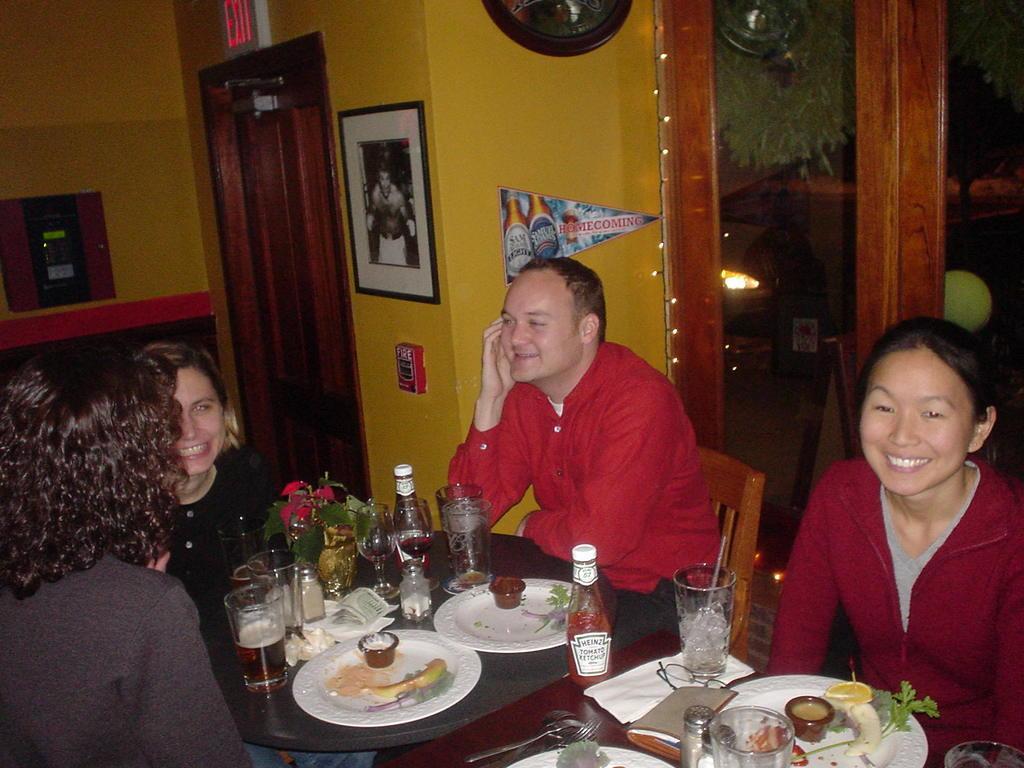Could you give a brief overview of what you see in this image? We can see photo frame over a wall. This is door and exit board. This is a cupboard. Here we can see lights. We can see four persons sitting on chairs in front of a table and on the table we can see bottle, plate of food, wine glasses, spoons and forks, spectacles. 